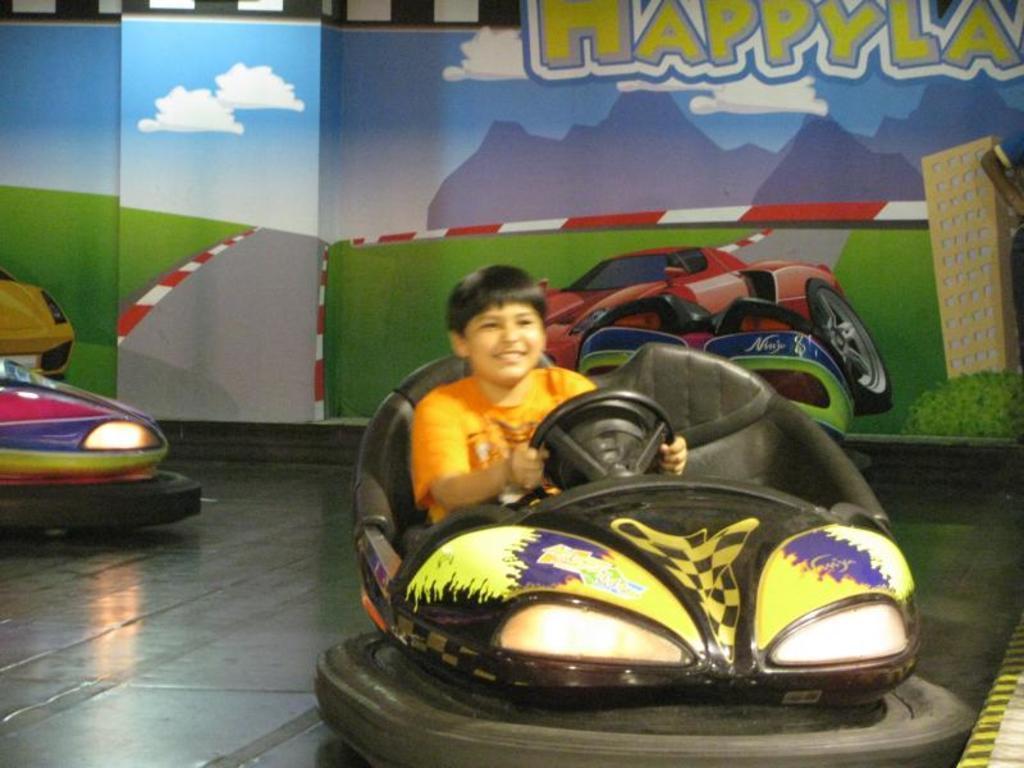Describe this image in one or two sentences. The picture consists of a boy sitting a cart and driving it. In the background we can find wall with full of painting. 